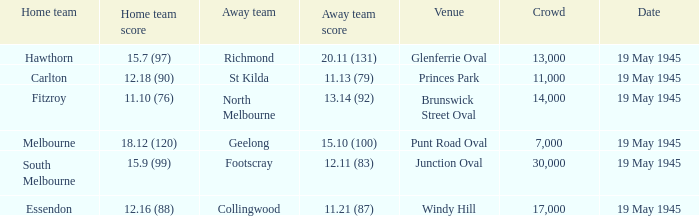On which date was a game played at Junction Oval? 19 May 1945. 